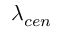<formula> <loc_0><loc_0><loc_500><loc_500>\lambda _ { c e n }</formula> 